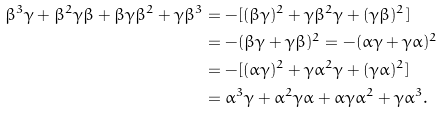Convert formula to latex. <formula><loc_0><loc_0><loc_500><loc_500>\beta ^ { 3 } \gamma + \beta ^ { 2 } \gamma \beta + \beta \gamma \beta ^ { 2 } + \gamma \beta ^ { 3 } & = - [ ( \beta \gamma ) ^ { 2 } + \gamma \beta ^ { 2 } \gamma + ( \gamma \beta ) ^ { 2 } ] \\ & = - ( \beta \gamma + \gamma \beta ) ^ { 2 } = - ( \alpha \gamma + \gamma \alpha ) ^ { 2 } \\ & = - [ ( \alpha \gamma ) ^ { 2 } + \gamma \alpha ^ { 2 } \gamma + ( \gamma \alpha ) ^ { 2 } ] \\ & = \alpha ^ { 3 } \gamma + \alpha ^ { 2 } \gamma \alpha + \alpha \gamma \alpha ^ { 2 } + \gamma \alpha ^ { 3 } .</formula> 